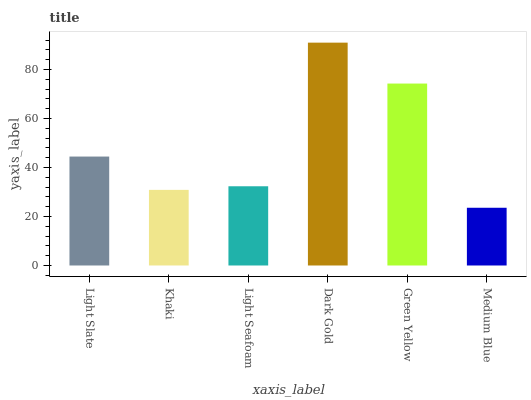Is Medium Blue the minimum?
Answer yes or no. Yes. Is Dark Gold the maximum?
Answer yes or no. Yes. Is Khaki the minimum?
Answer yes or no. No. Is Khaki the maximum?
Answer yes or no. No. Is Light Slate greater than Khaki?
Answer yes or no. Yes. Is Khaki less than Light Slate?
Answer yes or no. Yes. Is Khaki greater than Light Slate?
Answer yes or no. No. Is Light Slate less than Khaki?
Answer yes or no. No. Is Light Slate the high median?
Answer yes or no. Yes. Is Light Seafoam the low median?
Answer yes or no. Yes. Is Green Yellow the high median?
Answer yes or no. No. Is Khaki the low median?
Answer yes or no. No. 